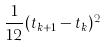Convert formula to latex. <formula><loc_0><loc_0><loc_500><loc_500>\frac { 1 } { 1 2 } ( t _ { k + 1 } - t _ { k } ) ^ { 2 }</formula> 